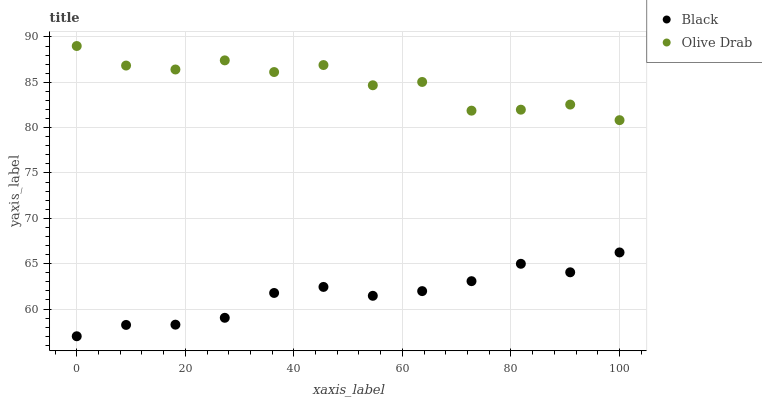Does Black have the minimum area under the curve?
Answer yes or no. Yes. Does Olive Drab have the maximum area under the curve?
Answer yes or no. Yes. Does Olive Drab have the minimum area under the curve?
Answer yes or no. No. Is Black the smoothest?
Answer yes or no. Yes. Is Olive Drab the roughest?
Answer yes or no. Yes. Is Olive Drab the smoothest?
Answer yes or no. No. Does Black have the lowest value?
Answer yes or no. Yes. Does Olive Drab have the lowest value?
Answer yes or no. No. Does Olive Drab have the highest value?
Answer yes or no. Yes. Is Black less than Olive Drab?
Answer yes or no. Yes. Is Olive Drab greater than Black?
Answer yes or no. Yes. Does Black intersect Olive Drab?
Answer yes or no. No. 